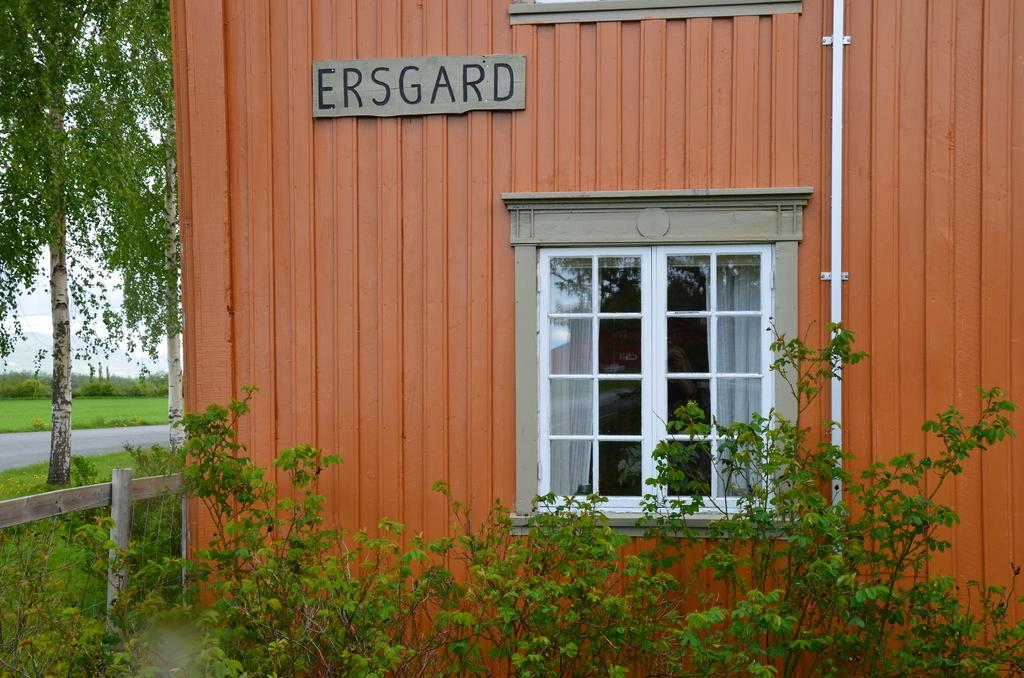What type of structure is visible in the image? There is a building with a window in the image. What can be seen in the foreground of the image? There is a group of plants and a wooden fence in the foreground. What is visible in the background of the image? There is a group of trees and the sky in the background. What type of jam is being spread on the wooden fence in the image? There is no jam present in the image; it features a building, plants, a wooden fence, trees, and the sky. 